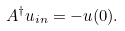<formula> <loc_0><loc_0><loc_500><loc_500>A ^ { \dagger } u _ { i n } = - u ( 0 ) .</formula> 